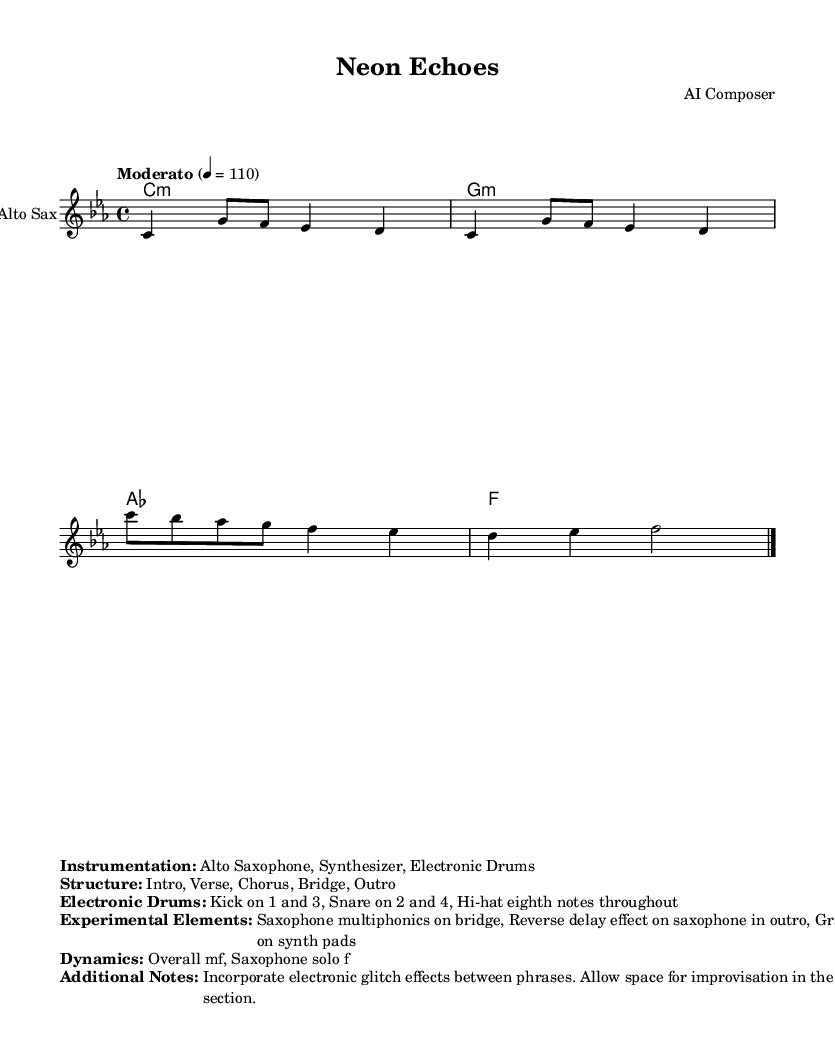What is the key signature of this music? The key signature is C minor, which has three flats (B, E, and A). This can be determined by looking for the key signature indicated at the beginning of the sheet music.
Answer: C minor What is the time signature? The time signature is 4/4, which indicates that there are four beats per measure and the quarter note gets one beat. This is visible at the start of the score.
Answer: 4/4 What is the tempo marking? The tempo marking is "Moderato" with a metronome mark of 110. This indicates the piece should be played at a moderate speed, specifically at 110 beats per minute.
Answer: Moderato, 110 What instruments are featured in the piece? The featured instruments include the Alto Saxophone, Synthesizer, and Electronic Drums. These instruments are listed in the instrumentation section immediately after the score.
Answer: Alto Saxophone, Synthesizer, Electronic Drums What is the structure of the piece? The structure includes an Intro, Verse, Chorus, Bridge, and Outro. This information is broadly stated in the score in the structure section below the music.
Answer: Intro, Verse, Chorus, Bridge, Outro In which section does the saxophone multiphonics occur? The saxophone multiphonics occur in the bridge section. This can be interpreted from the description of experimental elements provided in the sheet music.
Answer: Bridge What effect is used on the saxophone in the outro? A reverse delay effect is used on the saxophone in the outro. This is specified in the notes detailing the experimental elements of the piece.
Answer: Reverse delay effect 